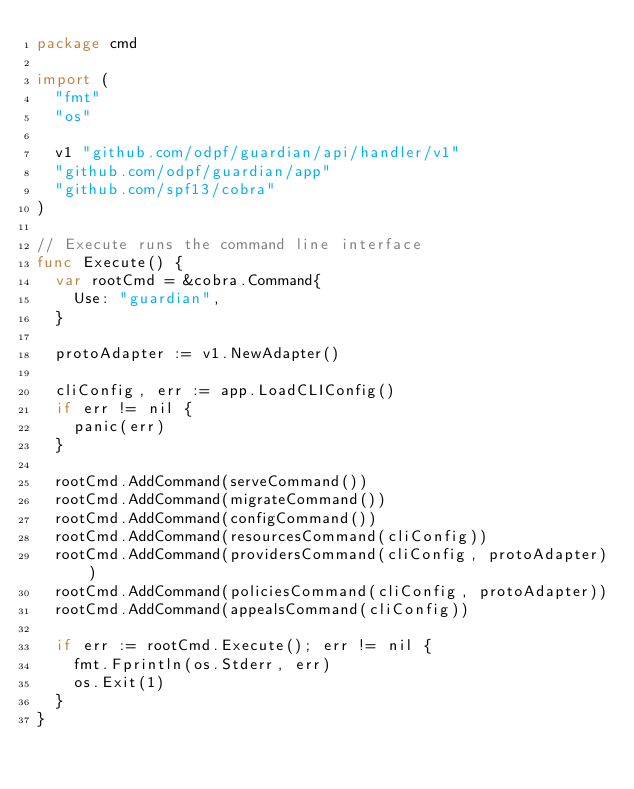<code> <loc_0><loc_0><loc_500><loc_500><_Go_>package cmd

import (
	"fmt"
	"os"

	v1 "github.com/odpf/guardian/api/handler/v1"
	"github.com/odpf/guardian/app"
	"github.com/spf13/cobra"
)

// Execute runs the command line interface
func Execute() {
	var rootCmd = &cobra.Command{
		Use: "guardian",
	}

	protoAdapter := v1.NewAdapter()

	cliConfig, err := app.LoadCLIConfig()
	if err != nil {
		panic(err)
	}

	rootCmd.AddCommand(serveCommand())
	rootCmd.AddCommand(migrateCommand())
	rootCmd.AddCommand(configCommand())
	rootCmd.AddCommand(resourcesCommand(cliConfig))
	rootCmd.AddCommand(providersCommand(cliConfig, protoAdapter))
	rootCmd.AddCommand(policiesCommand(cliConfig, protoAdapter))
	rootCmd.AddCommand(appealsCommand(cliConfig))

	if err := rootCmd.Execute(); err != nil {
		fmt.Fprintln(os.Stderr, err)
		os.Exit(1)
	}
}
</code> 